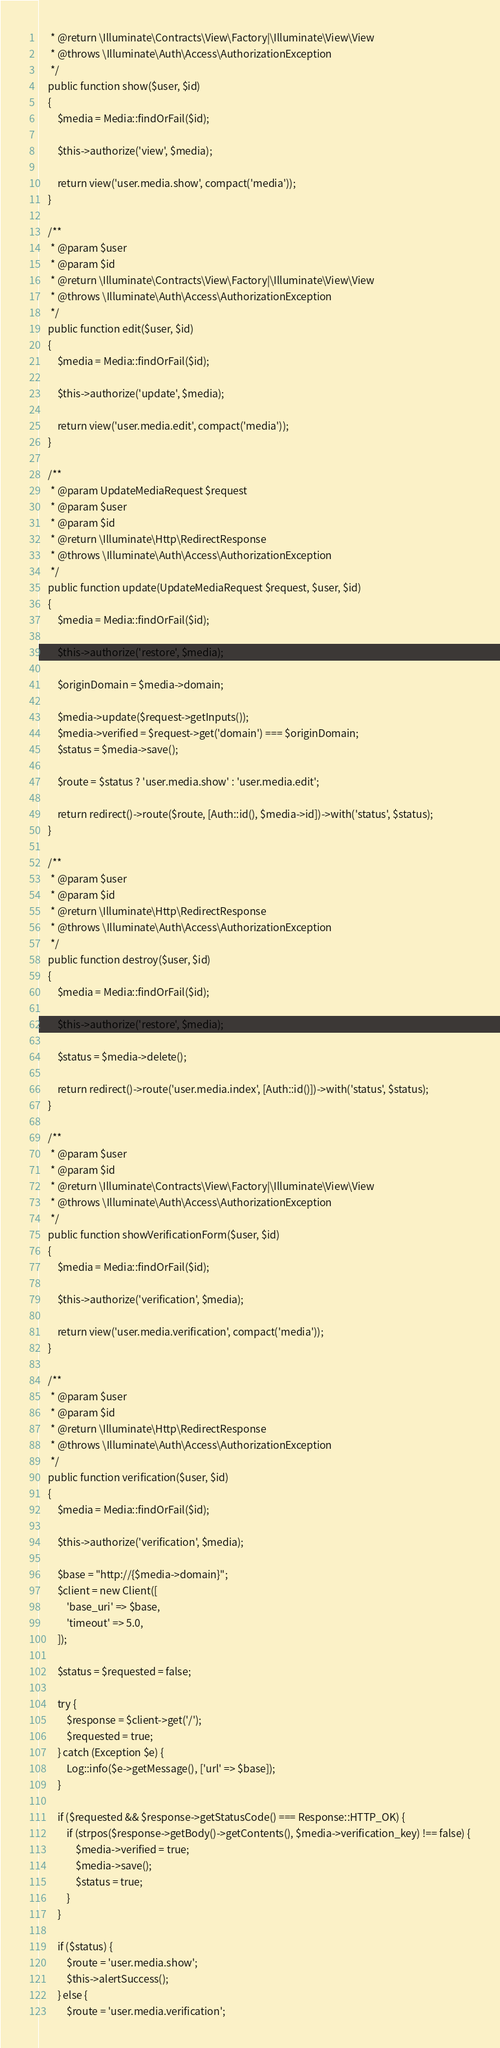<code> <loc_0><loc_0><loc_500><loc_500><_PHP_>     * @return \Illuminate\Contracts\View\Factory|\Illuminate\View\View
     * @throws \Illuminate\Auth\Access\AuthorizationException
     */
    public function show($user, $id)
    {
        $media = Media::findOrFail($id);

        $this->authorize('view', $media);

        return view('user.media.show', compact('media'));
    }

    /**
     * @param $user
     * @param $id
     * @return \Illuminate\Contracts\View\Factory|\Illuminate\View\View
     * @throws \Illuminate\Auth\Access\AuthorizationException
     */
    public function edit($user, $id)
    {
        $media = Media::findOrFail($id);

        $this->authorize('update', $media);

        return view('user.media.edit', compact('media'));
    }

    /**
     * @param UpdateMediaRequest $request
     * @param $user
     * @param $id
     * @return \Illuminate\Http\RedirectResponse
     * @throws \Illuminate\Auth\Access\AuthorizationException
     */
    public function update(UpdateMediaRequest $request, $user, $id)
    {
        $media = Media::findOrFail($id);

        $this->authorize('restore', $media);

        $originDomain = $media->domain;

        $media->update($request->getInputs());
        $media->verified = $request->get('domain') === $originDomain;
        $status = $media->save();

        $route = $status ? 'user.media.show' : 'user.media.edit';

        return redirect()->route($route, [Auth::id(), $media->id])->with('status', $status);
    }

    /**
     * @param $user
     * @param $id
     * @return \Illuminate\Http\RedirectResponse
     * @throws \Illuminate\Auth\Access\AuthorizationException
     */
    public function destroy($user, $id)
    {
        $media = Media::findOrFail($id);

        $this->authorize('restore', $media);

        $status = $media->delete();

        return redirect()->route('user.media.index', [Auth::id()])->with('status', $status);
    }

    /**
     * @param $user
     * @param $id
     * @return \Illuminate\Contracts\View\Factory|\Illuminate\View\View
     * @throws \Illuminate\Auth\Access\AuthorizationException
     */
    public function showVerificationForm($user, $id)
    {
        $media = Media::findOrFail($id);

        $this->authorize('verification', $media);

        return view('user.media.verification', compact('media'));
    }

    /**
     * @param $user
     * @param $id
     * @return \Illuminate\Http\RedirectResponse
     * @throws \Illuminate\Auth\Access\AuthorizationException
     */
    public function verification($user, $id)
    {
        $media = Media::findOrFail($id);

        $this->authorize('verification', $media);

        $base = "http://{$media->domain}";
        $client = new Client([
            'base_uri' => $base,
            'timeout' => 5.0,
        ]);

        $status = $requested = false;

        try {
            $response = $client->get('/');
            $requested = true;
        } catch (Exception $e) {
            Log::info($e->getMessage(), ['url' => $base]);
        }

        if ($requested && $response->getStatusCode() === Response::HTTP_OK) {
            if (strpos($response->getBody()->getContents(), $media->verification_key) !== false) {
                $media->verified = true;
                $media->save();
                $status = true;
            }
        }

        if ($status) {
            $route = 'user.media.show';
            $this->alertSuccess();
        } else {
            $route = 'user.media.verification';</code> 